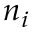Convert formula to latex. <formula><loc_0><loc_0><loc_500><loc_500>n _ { i }</formula> 